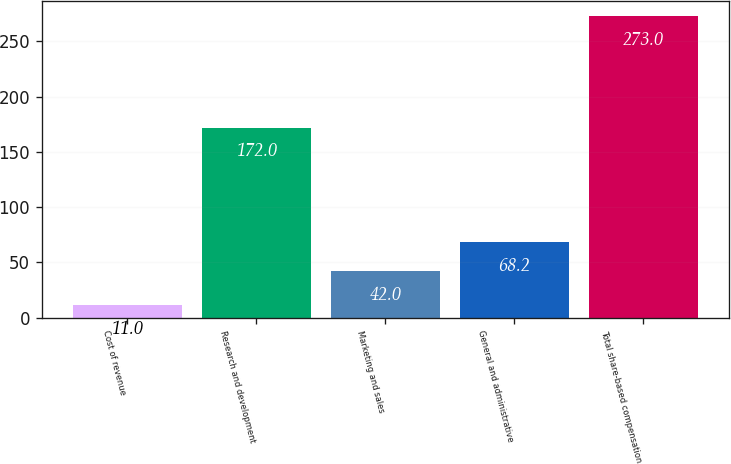Convert chart. <chart><loc_0><loc_0><loc_500><loc_500><bar_chart><fcel>Cost of revenue<fcel>Research and development<fcel>Marketing and sales<fcel>General and administrative<fcel>Total share-based compensation<nl><fcel>11<fcel>172<fcel>42<fcel>68.2<fcel>273<nl></chart> 